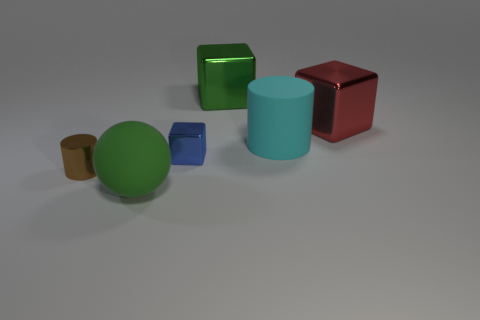Add 2 tiny brown things. How many objects exist? 8 Subtract all cylinders. How many objects are left? 4 Add 6 big green metal blocks. How many big green metal blocks exist? 7 Subtract 0 purple cylinders. How many objects are left? 6 Subtract all small cyan balls. Subtract all blue objects. How many objects are left? 5 Add 6 big cyan matte cylinders. How many big cyan matte cylinders are left? 7 